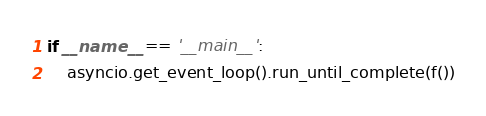<code> <loc_0><loc_0><loc_500><loc_500><_Python_>

if __name__ == '__main__':
    asyncio.get_event_loop().run_until_complete(f())
</code> 